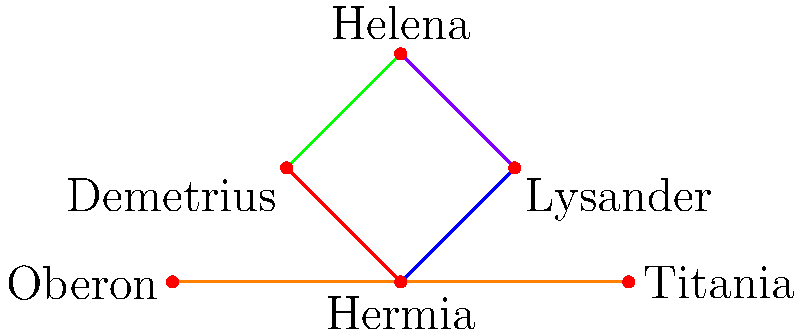In the network graph of character connections for A Midsummer Night's Dream, which character serves as a central node connecting the most love interests, and how does this reflect Shakespeare's use of dramatic irony in the play? To answer this question, let's analyze the network graph step-by-step:

1. Identify the characters: 
   - Hermia, Lysander, Demetrius, Helena, Oberon, and Titania

2. Examine the connections:
   - Hermia is connected to Lysander (blue) and Demetrius (red)
   - Helena is connected to Demetrius (green) and Lysander (purple)
   - Oberon and Titania are connected to each other (orange)

3. Count the love interest connections for each character:
   - Hermia: 2 (Lysander and Demetrius)
   - Lysander: 2 (Hermia and Helena)
   - Demetrius: 2 (Hermia and Helena)
   - Helena: 2 (Demetrius and Lysander)
   - Oberon: 1 (Titania)
   - Titania: 1 (Oberon)

4. Identify the central node:
   - While no single character connects to all others, the four mortal lovers (Hermia, Lysander, Demetrius, and Helena) form a complex web of connections.
   - Among these, Helena stands out as she is pursued by both Lysander and Demetrius at different points in the play.

5. Analyze the dramatic irony:
   - Helena's position as a central node reflects Shakespeare's use of dramatic irony.
   - Initially rejected by Demetrius, Helena becomes the object of both men's affections due to the magical intervention of Puck.
   - The audience knows about the love potion's effects, while the characters remain unaware, creating dramatic irony.

6. Consider the implications:
   - This central position of Helena in the love network emphasizes the chaos and confusion caused by the fairies' meddling.
   - It also highlights the theme of the fickleness of love and the blurred lines between reality and illusion in the play.
Answer: Helena; her central position reflects the dramatic irony of magical intervention in love. 